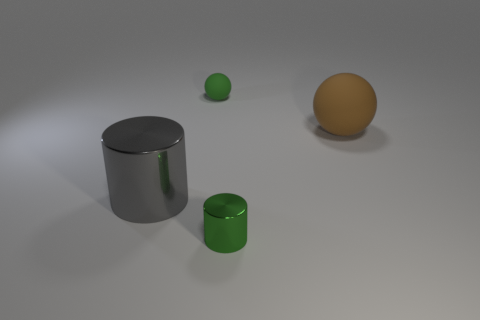How many large brown objects have the same material as the big sphere?
Provide a short and direct response. 0. Are there fewer small green cylinders than brown cylinders?
Provide a short and direct response. No. There is a cylinder that is left of the tiny green cylinder; is it the same color as the small matte thing?
Offer a very short reply. No. There is a cylinder that is right of the matte thing behind the brown matte sphere; what number of tiny cylinders are behind it?
Your answer should be compact. 0. There is a large rubber ball; what number of big things are in front of it?
Give a very brief answer. 1. What color is the tiny thing that is the same shape as the big gray object?
Ensure brevity in your answer.  Green. What is the thing that is both to the right of the big gray object and in front of the large matte ball made of?
Your answer should be compact. Metal. Is the size of the rubber object that is behind the brown matte object the same as the brown thing?
Keep it short and to the point. No. What is the material of the large cylinder?
Offer a very short reply. Metal. What is the color of the matte ball that is on the right side of the small shiny object?
Keep it short and to the point. Brown. 